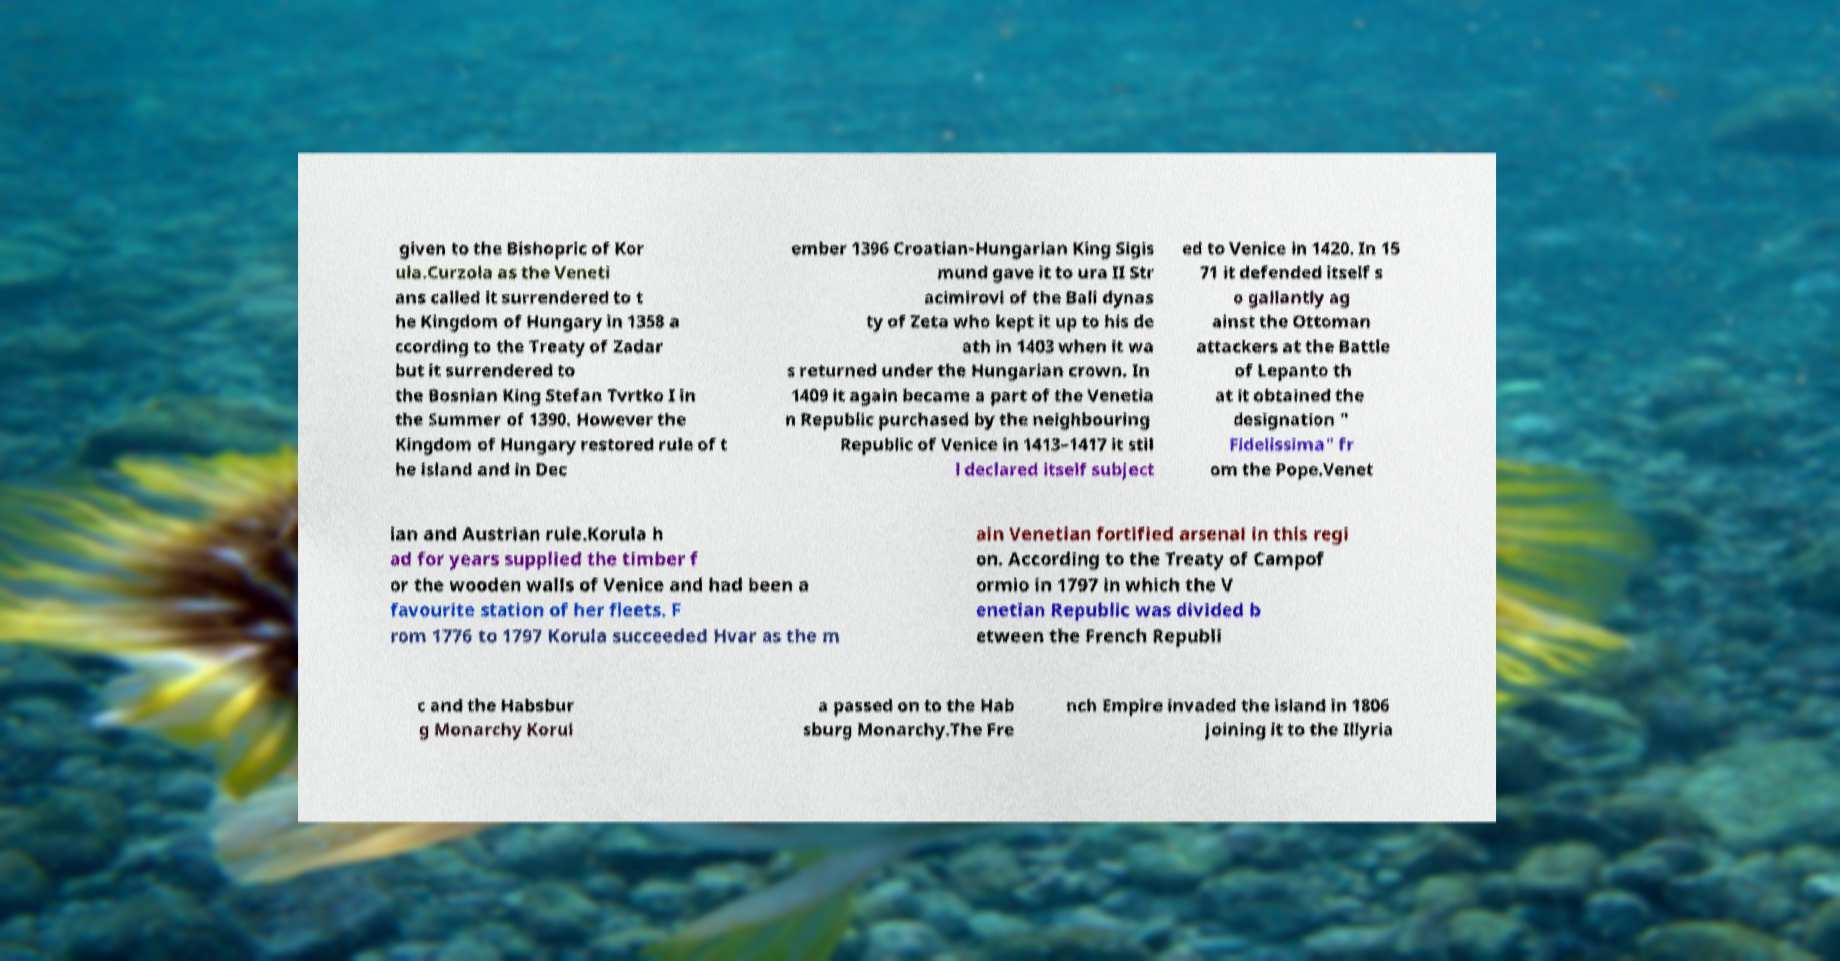For documentation purposes, I need the text within this image transcribed. Could you provide that? given to the Bishopric of Kor ula.Curzola as the Veneti ans called it surrendered to t he Kingdom of Hungary in 1358 a ccording to the Treaty of Zadar but it surrendered to the Bosnian King Stefan Tvrtko I in the Summer of 1390. However the Kingdom of Hungary restored rule of t he island and in Dec ember 1396 Croatian-Hungarian King Sigis mund gave it to ura II Str acimirovi of the Bali dynas ty of Zeta who kept it up to his de ath in 1403 when it wa s returned under the Hungarian crown. In 1409 it again became a part of the Venetia n Republic purchased by the neighbouring Republic of Venice in 1413–1417 it stil l declared itself subject ed to Venice in 1420. In 15 71 it defended itself s o gallantly ag ainst the Ottoman attackers at the Battle of Lepanto th at it obtained the designation " Fidelissima" fr om the Pope.Venet ian and Austrian rule.Korula h ad for years supplied the timber f or the wooden walls of Venice and had been a favourite station of her fleets. F rom 1776 to 1797 Korula succeeded Hvar as the m ain Venetian fortified arsenal in this regi on. According to the Treaty of Campof ormio in 1797 in which the V enetian Republic was divided b etween the French Republi c and the Habsbur g Monarchy Korul a passed on to the Hab sburg Monarchy.The Fre nch Empire invaded the island in 1806 joining it to the Illyria 